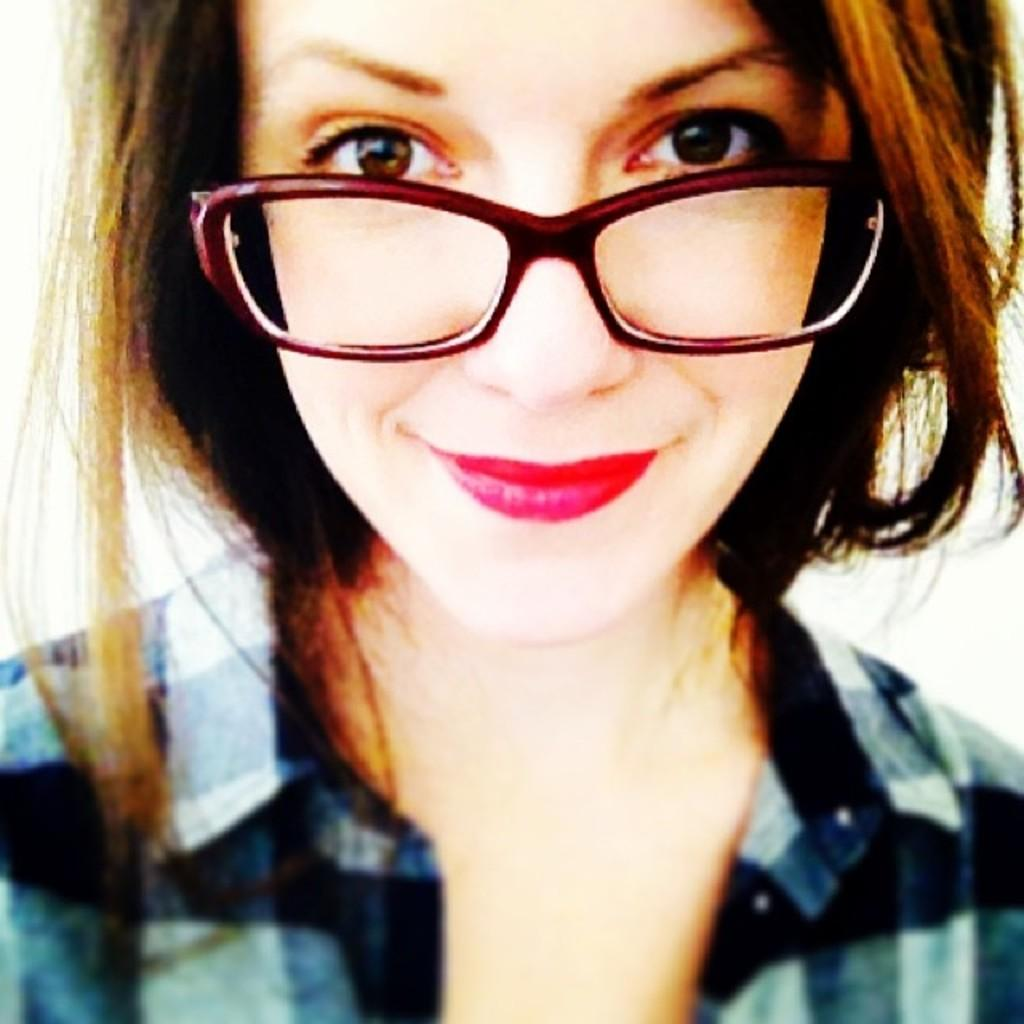Who is the main subject in the image? There is a woman in the image. What is the woman doing in the image? The woman is smiling. What accessory is the woman wearing in the image? The woman is wearing spectacles. How many pies does the woman create in the image? There is no mention of pies or the woman creating anything in the image. 